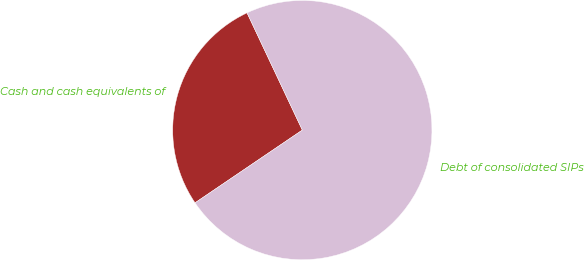<chart> <loc_0><loc_0><loc_500><loc_500><pie_chart><fcel>Cash and cash equivalents of<fcel>Debt of consolidated SIPs<nl><fcel>27.47%<fcel>72.53%<nl></chart> 